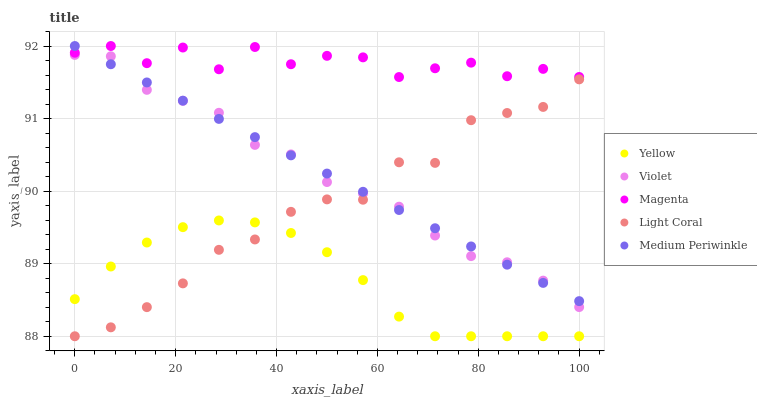Does Yellow have the minimum area under the curve?
Answer yes or no. Yes. Does Magenta have the maximum area under the curve?
Answer yes or no. Yes. Does Medium Periwinkle have the minimum area under the curve?
Answer yes or no. No. Does Medium Periwinkle have the maximum area under the curve?
Answer yes or no. No. Is Medium Periwinkle the smoothest?
Answer yes or no. Yes. Is Magenta the roughest?
Answer yes or no. Yes. Is Magenta the smoothest?
Answer yes or no. No. Is Medium Periwinkle the roughest?
Answer yes or no. No. Does Light Coral have the lowest value?
Answer yes or no. Yes. Does Medium Periwinkle have the lowest value?
Answer yes or no. No. Does Medium Periwinkle have the highest value?
Answer yes or no. Yes. Does Yellow have the highest value?
Answer yes or no. No. Is Yellow less than Violet?
Answer yes or no. Yes. Is Magenta greater than Yellow?
Answer yes or no. Yes. Does Violet intersect Medium Periwinkle?
Answer yes or no. Yes. Is Violet less than Medium Periwinkle?
Answer yes or no. No. Is Violet greater than Medium Periwinkle?
Answer yes or no. No. Does Yellow intersect Violet?
Answer yes or no. No. 